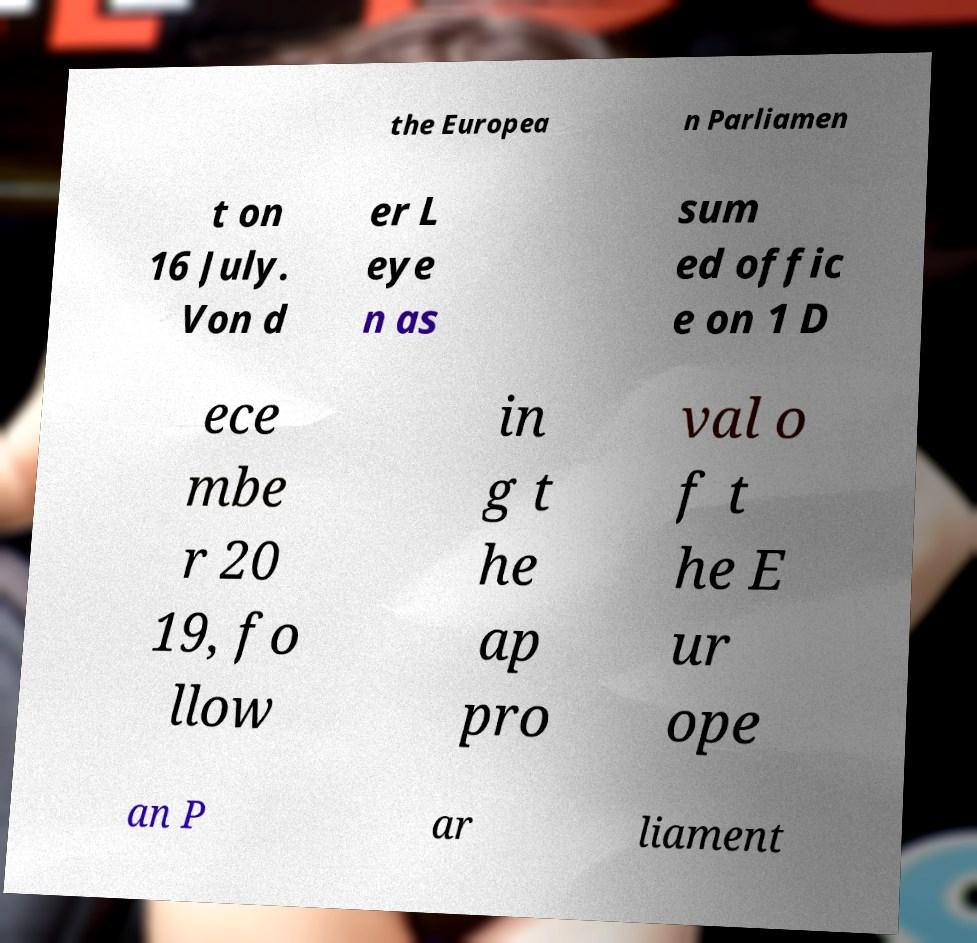Please identify and transcribe the text found in this image. the Europea n Parliamen t on 16 July. Von d er L eye n as sum ed offic e on 1 D ece mbe r 20 19, fo llow in g t he ap pro val o f t he E ur ope an P ar liament 